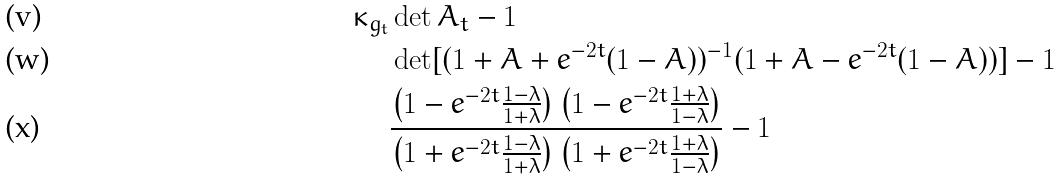Convert formula to latex. <formula><loc_0><loc_0><loc_500><loc_500>\kappa _ { g _ { t } } & \det A _ { t } - 1 \\ & \det [ ( 1 + A + e ^ { - 2 t } ( 1 - A ) ) ^ { - 1 } ( 1 + A - e ^ { - 2 t } ( 1 - A ) ) ] - 1 \\ & \frac { \left ( 1 - e ^ { - 2 t } \frac { 1 - \lambda } { 1 + \lambda } \right ) \left ( 1 - e ^ { - 2 t } \frac { 1 + \lambda } { 1 - \lambda } \right ) } { \left ( 1 + e ^ { - 2 t } \frac { 1 - \lambda } { 1 + \lambda } \right ) \left ( 1 + e ^ { - 2 t } \frac { 1 + \lambda } { 1 - \lambda } \right ) } - 1</formula> 